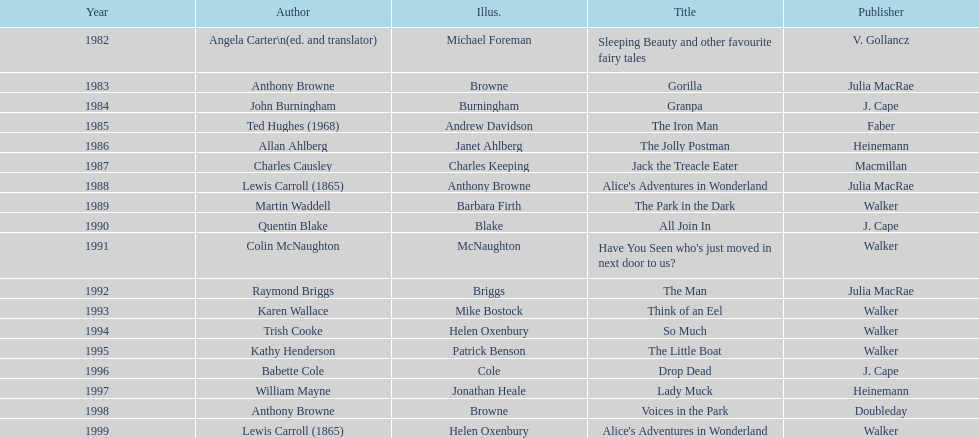Which other author, besides lewis carroll, has won the kurt maschler award twice? Anthony Browne. 